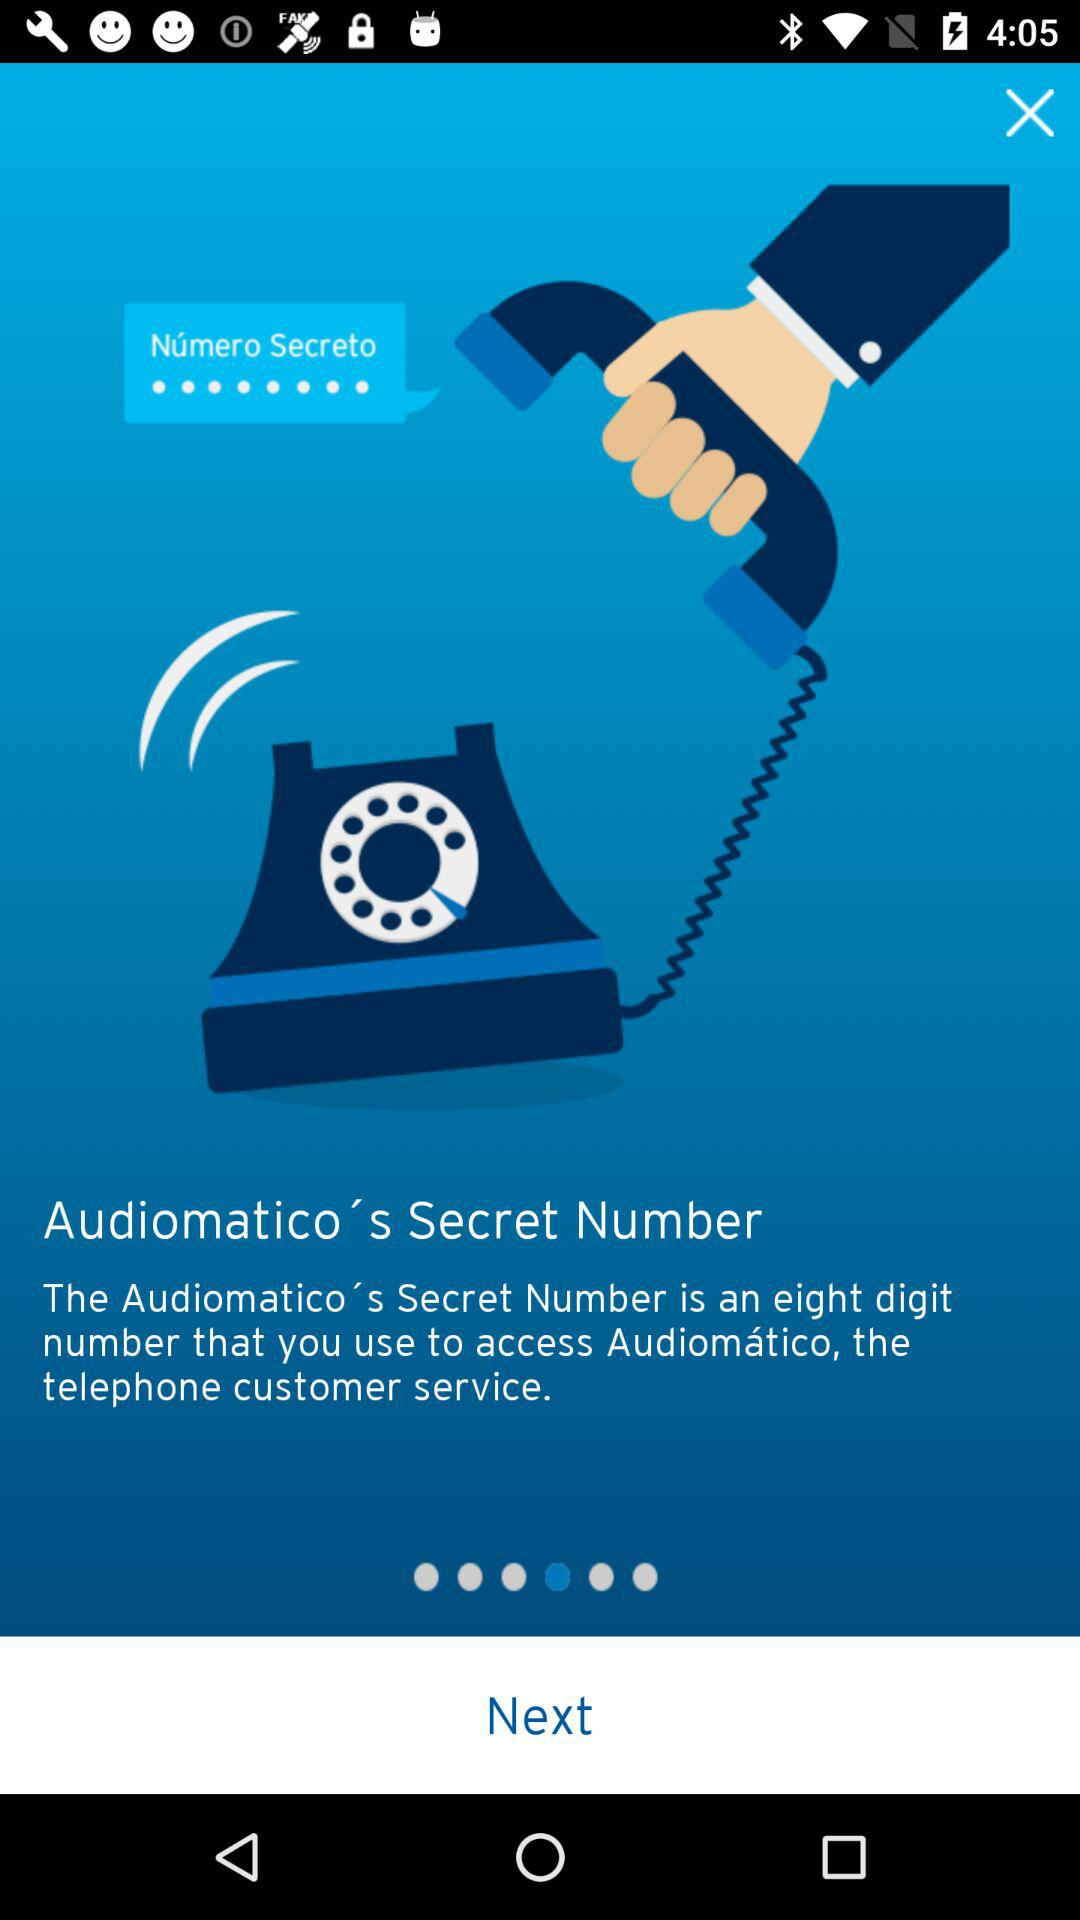How many digits are present in an audiomatico's secret number? There are eight digits present in an audiomatico's secret number. 